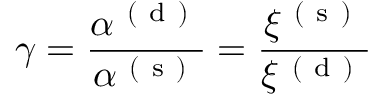Convert formula to latex. <formula><loc_0><loc_0><loc_500><loc_500>\gamma = \frac { \alpha ^ { ( d ) } } { \alpha ^ { ( s ) } } = \frac { \xi ^ { ( s ) } } { \xi ^ { ( d ) } }</formula> 